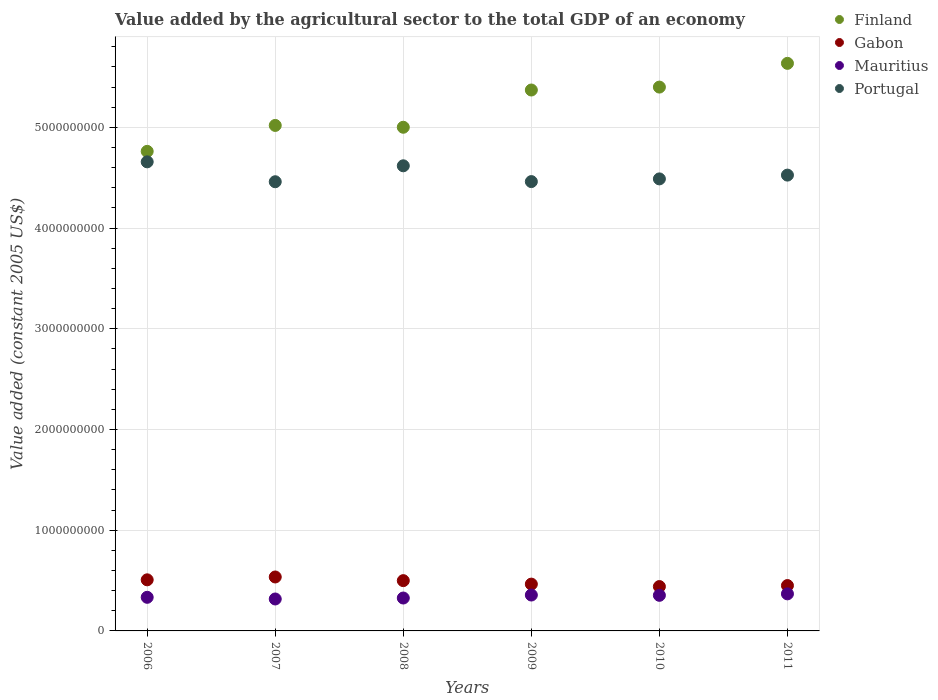How many different coloured dotlines are there?
Offer a terse response. 4. What is the value added by the agricultural sector in Mauritius in 2010?
Keep it short and to the point. 3.53e+08. Across all years, what is the maximum value added by the agricultural sector in Mauritius?
Make the answer very short. 3.68e+08. Across all years, what is the minimum value added by the agricultural sector in Finland?
Keep it short and to the point. 4.76e+09. In which year was the value added by the agricultural sector in Mauritius maximum?
Keep it short and to the point. 2011. In which year was the value added by the agricultural sector in Finland minimum?
Your answer should be compact. 2006. What is the total value added by the agricultural sector in Portugal in the graph?
Offer a very short reply. 2.72e+1. What is the difference between the value added by the agricultural sector in Mauritius in 2007 and that in 2010?
Give a very brief answer. -3.64e+07. What is the difference between the value added by the agricultural sector in Finland in 2011 and the value added by the agricultural sector in Mauritius in 2008?
Provide a succinct answer. 5.31e+09. What is the average value added by the agricultural sector in Portugal per year?
Keep it short and to the point. 4.54e+09. In the year 2008, what is the difference between the value added by the agricultural sector in Gabon and value added by the agricultural sector in Portugal?
Offer a terse response. -4.12e+09. In how many years, is the value added by the agricultural sector in Mauritius greater than 400000000 US$?
Keep it short and to the point. 0. What is the ratio of the value added by the agricultural sector in Mauritius in 2008 to that in 2011?
Provide a succinct answer. 0.89. Is the value added by the agricultural sector in Mauritius in 2006 less than that in 2010?
Your response must be concise. Yes. Is the difference between the value added by the agricultural sector in Gabon in 2008 and 2010 greater than the difference between the value added by the agricultural sector in Portugal in 2008 and 2010?
Keep it short and to the point. No. What is the difference between the highest and the second highest value added by the agricultural sector in Gabon?
Offer a very short reply. 2.83e+07. What is the difference between the highest and the lowest value added by the agricultural sector in Gabon?
Offer a very short reply. 9.51e+07. Is the sum of the value added by the agricultural sector in Mauritius in 2008 and 2009 greater than the maximum value added by the agricultural sector in Finland across all years?
Your response must be concise. No. Is the value added by the agricultural sector in Portugal strictly greater than the value added by the agricultural sector in Gabon over the years?
Offer a terse response. Yes. How many years are there in the graph?
Provide a succinct answer. 6. How many legend labels are there?
Keep it short and to the point. 4. How are the legend labels stacked?
Provide a short and direct response. Vertical. What is the title of the graph?
Ensure brevity in your answer.  Value added by the agricultural sector to the total GDP of an economy. Does "Indonesia" appear as one of the legend labels in the graph?
Your answer should be very brief. No. What is the label or title of the X-axis?
Keep it short and to the point. Years. What is the label or title of the Y-axis?
Ensure brevity in your answer.  Value added (constant 2005 US$). What is the Value added (constant 2005 US$) of Finland in 2006?
Keep it short and to the point. 4.76e+09. What is the Value added (constant 2005 US$) in Gabon in 2006?
Make the answer very short. 5.07e+08. What is the Value added (constant 2005 US$) in Mauritius in 2006?
Your answer should be compact. 3.34e+08. What is the Value added (constant 2005 US$) in Portugal in 2006?
Your response must be concise. 4.66e+09. What is the Value added (constant 2005 US$) of Finland in 2007?
Make the answer very short. 5.02e+09. What is the Value added (constant 2005 US$) of Gabon in 2007?
Your response must be concise. 5.36e+08. What is the Value added (constant 2005 US$) in Mauritius in 2007?
Keep it short and to the point. 3.17e+08. What is the Value added (constant 2005 US$) in Portugal in 2007?
Ensure brevity in your answer.  4.46e+09. What is the Value added (constant 2005 US$) of Finland in 2008?
Give a very brief answer. 5.00e+09. What is the Value added (constant 2005 US$) of Gabon in 2008?
Your answer should be very brief. 4.99e+08. What is the Value added (constant 2005 US$) of Mauritius in 2008?
Your answer should be very brief. 3.27e+08. What is the Value added (constant 2005 US$) of Portugal in 2008?
Keep it short and to the point. 4.62e+09. What is the Value added (constant 2005 US$) of Finland in 2009?
Keep it short and to the point. 5.37e+09. What is the Value added (constant 2005 US$) of Gabon in 2009?
Your answer should be very brief. 4.65e+08. What is the Value added (constant 2005 US$) in Mauritius in 2009?
Make the answer very short. 3.56e+08. What is the Value added (constant 2005 US$) of Portugal in 2009?
Offer a terse response. 4.46e+09. What is the Value added (constant 2005 US$) in Finland in 2010?
Your answer should be compact. 5.40e+09. What is the Value added (constant 2005 US$) of Gabon in 2010?
Provide a succinct answer. 4.40e+08. What is the Value added (constant 2005 US$) of Mauritius in 2010?
Ensure brevity in your answer.  3.53e+08. What is the Value added (constant 2005 US$) of Portugal in 2010?
Ensure brevity in your answer.  4.49e+09. What is the Value added (constant 2005 US$) of Finland in 2011?
Offer a very short reply. 5.64e+09. What is the Value added (constant 2005 US$) in Gabon in 2011?
Your answer should be compact. 4.50e+08. What is the Value added (constant 2005 US$) of Mauritius in 2011?
Your answer should be very brief. 3.68e+08. What is the Value added (constant 2005 US$) of Portugal in 2011?
Ensure brevity in your answer.  4.53e+09. Across all years, what is the maximum Value added (constant 2005 US$) in Finland?
Offer a very short reply. 5.64e+09. Across all years, what is the maximum Value added (constant 2005 US$) in Gabon?
Offer a very short reply. 5.36e+08. Across all years, what is the maximum Value added (constant 2005 US$) in Mauritius?
Give a very brief answer. 3.68e+08. Across all years, what is the maximum Value added (constant 2005 US$) in Portugal?
Provide a succinct answer. 4.66e+09. Across all years, what is the minimum Value added (constant 2005 US$) of Finland?
Make the answer very short. 4.76e+09. Across all years, what is the minimum Value added (constant 2005 US$) of Gabon?
Your response must be concise. 4.40e+08. Across all years, what is the minimum Value added (constant 2005 US$) of Mauritius?
Your answer should be very brief. 3.17e+08. Across all years, what is the minimum Value added (constant 2005 US$) of Portugal?
Offer a terse response. 4.46e+09. What is the total Value added (constant 2005 US$) of Finland in the graph?
Your answer should be compact. 3.12e+1. What is the total Value added (constant 2005 US$) of Gabon in the graph?
Give a very brief answer. 2.90e+09. What is the total Value added (constant 2005 US$) of Mauritius in the graph?
Make the answer very short. 2.06e+09. What is the total Value added (constant 2005 US$) of Portugal in the graph?
Keep it short and to the point. 2.72e+1. What is the difference between the Value added (constant 2005 US$) of Finland in 2006 and that in 2007?
Offer a very short reply. -2.57e+08. What is the difference between the Value added (constant 2005 US$) in Gabon in 2006 and that in 2007?
Provide a short and direct response. -2.83e+07. What is the difference between the Value added (constant 2005 US$) in Mauritius in 2006 and that in 2007?
Your answer should be very brief. 1.67e+07. What is the difference between the Value added (constant 2005 US$) in Portugal in 2006 and that in 2007?
Provide a succinct answer. 1.98e+08. What is the difference between the Value added (constant 2005 US$) of Finland in 2006 and that in 2008?
Give a very brief answer. -2.39e+08. What is the difference between the Value added (constant 2005 US$) of Gabon in 2006 and that in 2008?
Provide a short and direct response. 8.09e+06. What is the difference between the Value added (constant 2005 US$) of Mauritius in 2006 and that in 2008?
Offer a terse response. 7.18e+06. What is the difference between the Value added (constant 2005 US$) in Portugal in 2006 and that in 2008?
Ensure brevity in your answer.  3.93e+07. What is the difference between the Value added (constant 2005 US$) of Finland in 2006 and that in 2009?
Your answer should be compact. -6.09e+08. What is the difference between the Value added (constant 2005 US$) in Gabon in 2006 and that in 2009?
Make the answer very short. 4.26e+07. What is the difference between the Value added (constant 2005 US$) of Mauritius in 2006 and that in 2009?
Your answer should be very brief. -2.25e+07. What is the difference between the Value added (constant 2005 US$) in Portugal in 2006 and that in 2009?
Ensure brevity in your answer.  1.96e+08. What is the difference between the Value added (constant 2005 US$) of Finland in 2006 and that in 2010?
Offer a terse response. -6.38e+08. What is the difference between the Value added (constant 2005 US$) of Gabon in 2006 and that in 2010?
Your response must be concise. 6.69e+07. What is the difference between the Value added (constant 2005 US$) of Mauritius in 2006 and that in 2010?
Offer a very short reply. -1.97e+07. What is the difference between the Value added (constant 2005 US$) of Portugal in 2006 and that in 2010?
Make the answer very short. 1.69e+08. What is the difference between the Value added (constant 2005 US$) in Finland in 2006 and that in 2011?
Make the answer very short. -8.74e+08. What is the difference between the Value added (constant 2005 US$) of Gabon in 2006 and that in 2011?
Give a very brief answer. 5.69e+07. What is the difference between the Value added (constant 2005 US$) in Mauritius in 2006 and that in 2011?
Ensure brevity in your answer.  -3.42e+07. What is the difference between the Value added (constant 2005 US$) in Portugal in 2006 and that in 2011?
Ensure brevity in your answer.  1.32e+08. What is the difference between the Value added (constant 2005 US$) in Finland in 2007 and that in 2008?
Offer a very short reply. 1.81e+07. What is the difference between the Value added (constant 2005 US$) of Gabon in 2007 and that in 2008?
Make the answer very short. 3.63e+07. What is the difference between the Value added (constant 2005 US$) in Mauritius in 2007 and that in 2008?
Offer a very short reply. -9.51e+06. What is the difference between the Value added (constant 2005 US$) in Portugal in 2007 and that in 2008?
Give a very brief answer. -1.58e+08. What is the difference between the Value added (constant 2005 US$) in Finland in 2007 and that in 2009?
Give a very brief answer. -3.52e+08. What is the difference between the Value added (constant 2005 US$) of Gabon in 2007 and that in 2009?
Keep it short and to the point. 7.09e+07. What is the difference between the Value added (constant 2005 US$) of Mauritius in 2007 and that in 2009?
Your answer should be very brief. -3.92e+07. What is the difference between the Value added (constant 2005 US$) in Portugal in 2007 and that in 2009?
Provide a succinct answer. -1.43e+06. What is the difference between the Value added (constant 2005 US$) of Finland in 2007 and that in 2010?
Provide a short and direct response. -3.81e+08. What is the difference between the Value added (constant 2005 US$) in Gabon in 2007 and that in 2010?
Your response must be concise. 9.51e+07. What is the difference between the Value added (constant 2005 US$) of Mauritius in 2007 and that in 2010?
Your answer should be very brief. -3.64e+07. What is the difference between the Value added (constant 2005 US$) of Portugal in 2007 and that in 2010?
Ensure brevity in your answer.  -2.83e+07. What is the difference between the Value added (constant 2005 US$) of Finland in 2007 and that in 2011?
Offer a very short reply. -6.16e+08. What is the difference between the Value added (constant 2005 US$) in Gabon in 2007 and that in 2011?
Keep it short and to the point. 8.52e+07. What is the difference between the Value added (constant 2005 US$) in Mauritius in 2007 and that in 2011?
Give a very brief answer. -5.09e+07. What is the difference between the Value added (constant 2005 US$) of Portugal in 2007 and that in 2011?
Your response must be concise. -6.58e+07. What is the difference between the Value added (constant 2005 US$) of Finland in 2008 and that in 2009?
Offer a terse response. -3.70e+08. What is the difference between the Value added (constant 2005 US$) of Gabon in 2008 and that in 2009?
Provide a short and direct response. 3.45e+07. What is the difference between the Value added (constant 2005 US$) of Mauritius in 2008 and that in 2009?
Keep it short and to the point. -2.97e+07. What is the difference between the Value added (constant 2005 US$) of Portugal in 2008 and that in 2009?
Offer a terse response. 1.57e+08. What is the difference between the Value added (constant 2005 US$) in Finland in 2008 and that in 2010?
Your answer should be very brief. -3.99e+08. What is the difference between the Value added (constant 2005 US$) in Gabon in 2008 and that in 2010?
Ensure brevity in your answer.  5.88e+07. What is the difference between the Value added (constant 2005 US$) in Mauritius in 2008 and that in 2010?
Provide a short and direct response. -2.69e+07. What is the difference between the Value added (constant 2005 US$) of Portugal in 2008 and that in 2010?
Make the answer very short. 1.30e+08. What is the difference between the Value added (constant 2005 US$) of Finland in 2008 and that in 2011?
Your answer should be compact. -6.34e+08. What is the difference between the Value added (constant 2005 US$) in Gabon in 2008 and that in 2011?
Provide a succinct answer. 4.89e+07. What is the difference between the Value added (constant 2005 US$) of Mauritius in 2008 and that in 2011?
Your answer should be very brief. -4.14e+07. What is the difference between the Value added (constant 2005 US$) in Portugal in 2008 and that in 2011?
Provide a short and direct response. 9.24e+07. What is the difference between the Value added (constant 2005 US$) in Finland in 2009 and that in 2010?
Your answer should be compact. -2.90e+07. What is the difference between the Value added (constant 2005 US$) of Gabon in 2009 and that in 2010?
Make the answer very short. 2.42e+07. What is the difference between the Value added (constant 2005 US$) of Mauritius in 2009 and that in 2010?
Give a very brief answer. 2.85e+06. What is the difference between the Value added (constant 2005 US$) in Portugal in 2009 and that in 2010?
Your response must be concise. -2.68e+07. What is the difference between the Value added (constant 2005 US$) of Finland in 2009 and that in 2011?
Make the answer very short. -2.65e+08. What is the difference between the Value added (constant 2005 US$) in Gabon in 2009 and that in 2011?
Ensure brevity in your answer.  1.43e+07. What is the difference between the Value added (constant 2005 US$) in Mauritius in 2009 and that in 2011?
Make the answer very short. -1.16e+07. What is the difference between the Value added (constant 2005 US$) in Portugal in 2009 and that in 2011?
Your response must be concise. -6.44e+07. What is the difference between the Value added (constant 2005 US$) in Finland in 2010 and that in 2011?
Offer a terse response. -2.36e+08. What is the difference between the Value added (constant 2005 US$) of Gabon in 2010 and that in 2011?
Your response must be concise. -9.92e+06. What is the difference between the Value added (constant 2005 US$) in Mauritius in 2010 and that in 2011?
Make the answer very short. -1.45e+07. What is the difference between the Value added (constant 2005 US$) in Portugal in 2010 and that in 2011?
Offer a very short reply. -3.76e+07. What is the difference between the Value added (constant 2005 US$) of Finland in 2006 and the Value added (constant 2005 US$) of Gabon in 2007?
Offer a terse response. 4.23e+09. What is the difference between the Value added (constant 2005 US$) of Finland in 2006 and the Value added (constant 2005 US$) of Mauritius in 2007?
Your response must be concise. 4.44e+09. What is the difference between the Value added (constant 2005 US$) in Finland in 2006 and the Value added (constant 2005 US$) in Portugal in 2007?
Give a very brief answer. 3.02e+08. What is the difference between the Value added (constant 2005 US$) in Gabon in 2006 and the Value added (constant 2005 US$) in Mauritius in 2007?
Offer a very short reply. 1.90e+08. What is the difference between the Value added (constant 2005 US$) of Gabon in 2006 and the Value added (constant 2005 US$) of Portugal in 2007?
Your response must be concise. -3.95e+09. What is the difference between the Value added (constant 2005 US$) of Mauritius in 2006 and the Value added (constant 2005 US$) of Portugal in 2007?
Ensure brevity in your answer.  -4.13e+09. What is the difference between the Value added (constant 2005 US$) in Finland in 2006 and the Value added (constant 2005 US$) in Gabon in 2008?
Provide a short and direct response. 4.26e+09. What is the difference between the Value added (constant 2005 US$) of Finland in 2006 and the Value added (constant 2005 US$) of Mauritius in 2008?
Provide a short and direct response. 4.43e+09. What is the difference between the Value added (constant 2005 US$) in Finland in 2006 and the Value added (constant 2005 US$) in Portugal in 2008?
Your answer should be very brief. 1.43e+08. What is the difference between the Value added (constant 2005 US$) of Gabon in 2006 and the Value added (constant 2005 US$) of Mauritius in 2008?
Provide a succinct answer. 1.81e+08. What is the difference between the Value added (constant 2005 US$) of Gabon in 2006 and the Value added (constant 2005 US$) of Portugal in 2008?
Ensure brevity in your answer.  -4.11e+09. What is the difference between the Value added (constant 2005 US$) of Mauritius in 2006 and the Value added (constant 2005 US$) of Portugal in 2008?
Keep it short and to the point. -4.28e+09. What is the difference between the Value added (constant 2005 US$) in Finland in 2006 and the Value added (constant 2005 US$) in Gabon in 2009?
Provide a short and direct response. 4.30e+09. What is the difference between the Value added (constant 2005 US$) of Finland in 2006 and the Value added (constant 2005 US$) of Mauritius in 2009?
Give a very brief answer. 4.41e+09. What is the difference between the Value added (constant 2005 US$) in Finland in 2006 and the Value added (constant 2005 US$) in Portugal in 2009?
Your response must be concise. 3.00e+08. What is the difference between the Value added (constant 2005 US$) in Gabon in 2006 and the Value added (constant 2005 US$) in Mauritius in 2009?
Offer a very short reply. 1.51e+08. What is the difference between the Value added (constant 2005 US$) of Gabon in 2006 and the Value added (constant 2005 US$) of Portugal in 2009?
Offer a very short reply. -3.95e+09. What is the difference between the Value added (constant 2005 US$) of Mauritius in 2006 and the Value added (constant 2005 US$) of Portugal in 2009?
Offer a terse response. -4.13e+09. What is the difference between the Value added (constant 2005 US$) in Finland in 2006 and the Value added (constant 2005 US$) in Gabon in 2010?
Give a very brief answer. 4.32e+09. What is the difference between the Value added (constant 2005 US$) of Finland in 2006 and the Value added (constant 2005 US$) of Mauritius in 2010?
Offer a terse response. 4.41e+09. What is the difference between the Value added (constant 2005 US$) in Finland in 2006 and the Value added (constant 2005 US$) in Portugal in 2010?
Your response must be concise. 2.73e+08. What is the difference between the Value added (constant 2005 US$) in Gabon in 2006 and the Value added (constant 2005 US$) in Mauritius in 2010?
Your answer should be compact. 1.54e+08. What is the difference between the Value added (constant 2005 US$) in Gabon in 2006 and the Value added (constant 2005 US$) in Portugal in 2010?
Give a very brief answer. -3.98e+09. What is the difference between the Value added (constant 2005 US$) in Mauritius in 2006 and the Value added (constant 2005 US$) in Portugal in 2010?
Your response must be concise. -4.15e+09. What is the difference between the Value added (constant 2005 US$) of Finland in 2006 and the Value added (constant 2005 US$) of Gabon in 2011?
Make the answer very short. 4.31e+09. What is the difference between the Value added (constant 2005 US$) in Finland in 2006 and the Value added (constant 2005 US$) in Mauritius in 2011?
Offer a terse response. 4.39e+09. What is the difference between the Value added (constant 2005 US$) in Finland in 2006 and the Value added (constant 2005 US$) in Portugal in 2011?
Offer a very short reply. 2.36e+08. What is the difference between the Value added (constant 2005 US$) in Gabon in 2006 and the Value added (constant 2005 US$) in Mauritius in 2011?
Provide a succinct answer. 1.39e+08. What is the difference between the Value added (constant 2005 US$) in Gabon in 2006 and the Value added (constant 2005 US$) in Portugal in 2011?
Your answer should be compact. -4.02e+09. What is the difference between the Value added (constant 2005 US$) of Mauritius in 2006 and the Value added (constant 2005 US$) of Portugal in 2011?
Offer a very short reply. -4.19e+09. What is the difference between the Value added (constant 2005 US$) of Finland in 2007 and the Value added (constant 2005 US$) of Gabon in 2008?
Offer a very short reply. 4.52e+09. What is the difference between the Value added (constant 2005 US$) of Finland in 2007 and the Value added (constant 2005 US$) of Mauritius in 2008?
Keep it short and to the point. 4.69e+09. What is the difference between the Value added (constant 2005 US$) of Finland in 2007 and the Value added (constant 2005 US$) of Portugal in 2008?
Ensure brevity in your answer.  4.01e+08. What is the difference between the Value added (constant 2005 US$) of Gabon in 2007 and the Value added (constant 2005 US$) of Mauritius in 2008?
Provide a short and direct response. 2.09e+08. What is the difference between the Value added (constant 2005 US$) of Gabon in 2007 and the Value added (constant 2005 US$) of Portugal in 2008?
Make the answer very short. -4.08e+09. What is the difference between the Value added (constant 2005 US$) in Mauritius in 2007 and the Value added (constant 2005 US$) in Portugal in 2008?
Your response must be concise. -4.30e+09. What is the difference between the Value added (constant 2005 US$) of Finland in 2007 and the Value added (constant 2005 US$) of Gabon in 2009?
Offer a terse response. 4.55e+09. What is the difference between the Value added (constant 2005 US$) in Finland in 2007 and the Value added (constant 2005 US$) in Mauritius in 2009?
Your answer should be very brief. 4.66e+09. What is the difference between the Value added (constant 2005 US$) of Finland in 2007 and the Value added (constant 2005 US$) of Portugal in 2009?
Your answer should be very brief. 5.58e+08. What is the difference between the Value added (constant 2005 US$) of Gabon in 2007 and the Value added (constant 2005 US$) of Mauritius in 2009?
Ensure brevity in your answer.  1.79e+08. What is the difference between the Value added (constant 2005 US$) of Gabon in 2007 and the Value added (constant 2005 US$) of Portugal in 2009?
Ensure brevity in your answer.  -3.93e+09. What is the difference between the Value added (constant 2005 US$) of Mauritius in 2007 and the Value added (constant 2005 US$) of Portugal in 2009?
Your response must be concise. -4.14e+09. What is the difference between the Value added (constant 2005 US$) in Finland in 2007 and the Value added (constant 2005 US$) in Gabon in 2010?
Give a very brief answer. 4.58e+09. What is the difference between the Value added (constant 2005 US$) of Finland in 2007 and the Value added (constant 2005 US$) of Mauritius in 2010?
Your answer should be compact. 4.67e+09. What is the difference between the Value added (constant 2005 US$) of Finland in 2007 and the Value added (constant 2005 US$) of Portugal in 2010?
Keep it short and to the point. 5.31e+08. What is the difference between the Value added (constant 2005 US$) of Gabon in 2007 and the Value added (constant 2005 US$) of Mauritius in 2010?
Ensure brevity in your answer.  1.82e+08. What is the difference between the Value added (constant 2005 US$) of Gabon in 2007 and the Value added (constant 2005 US$) of Portugal in 2010?
Offer a very short reply. -3.95e+09. What is the difference between the Value added (constant 2005 US$) in Mauritius in 2007 and the Value added (constant 2005 US$) in Portugal in 2010?
Keep it short and to the point. -4.17e+09. What is the difference between the Value added (constant 2005 US$) of Finland in 2007 and the Value added (constant 2005 US$) of Gabon in 2011?
Your response must be concise. 4.57e+09. What is the difference between the Value added (constant 2005 US$) in Finland in 2007 and the Value added (constant 2005 US$) in Mauritius in 2011?
Your answer should be compact. 4.65e+09. What is the difference between the Value added (constant 2005 US$) in Finland in 2007 and the Value added (constant 2005 US$) in Portugal in 2011?
Ensure brevity in your answer.  4.93e+08. What is the difference between the Value added (constant 2005 US$) in Gabon in 2007 and the Value added (constant 2005 US$) in Mauritius in 2011?
Give a very brief answer. 1.68e+08. What is the difference between the Value added (constant 2005 US$) in Gabon in 2007 and the Value added (constant 2005 US$) in Portugal in 2011?
Provide a short and direct response. -3.99e+09. What is the difference between the Value added (constant 2005 US$) of Mauritius in 2007 and the Value added (constant 2005 US$) of Portugal in 2011?
Offer a terse response. -4.21e+09. What is the difference between the Value added (constant 2005 US$) in Finland in 2008 and the Value added (constant 2005 US$) in Gabon in 2009?
Offer a terse response. 4.54e+09. What is the difference between the Value added (constant 2005 US$) in Finland in 2008 and the Value added (constant 2005 US$) in Mauritius in 2009?
Provide a short and direct response. 4.64e+09. What is the difference between the Value added (constant 2005 US$) in Finland in 2008 and the Value added (constant 2005 US$) in Portugal in 2009?
Your response must be concise. 5.40e+08. What is the difference between the Value added (constant 2005 US$) of Gabon in 2008 and the Value added (constant 2005 US$) of Mauritius in 2009?
Ensure brevity in your answer.  1.43e+08. What is the difference between the Value added (constant 2005 US$) of Gabon in 2008 and the Value added (constant 2005 US$) of Portugal in 2009?
Offer a terse response. -3.96e+09. What is the difference between the Value added (constant 2005 US$) in Mauritius in 2008 and the Value added (constant 2005 US$) in Portugal in 2009?
Give a very brief answer. -4.13e+09. What is the difference between the Value added (constant 2005 US$) in Finland in 2008 and the Value added (constant 2005 US$) in Gabon in 2010?
Offer a terse response. 4.56e+09. What is the difference between the Value added (constant 2005 US$) in Finland in 2008 and the Value added (constant 2005 US$) in Mauritius in 2010?
Provide a succinct answer. 4.65e+09. What is the difference between the Value added (constant 2005 US$) in Finland in 2008 and the Value added (constant 2005 US$) in Portugal in 2010?
Your answer should be very brief. 5.13e+08. What is the difference between the Value added (constant 2005 US$) in Gabon in 2008 and the Value added (constant 2005 US$) in Mauritius in 2010?
Make the answer very short. 1.46e+08. What is the difference between the Value added (constant 2005 US$) of Gabon in 2008 and the Value added (constant 2005 US$) of Portugal in 2010?
Provide a succinct answer. -3.99e+09. What is the difference between the Value added (constant 2005 US$) in Mauritius in 2008 and the Value added (constant 2005 US$) in Portugal in 2010?
Provide a short and direct response. -4.16e+09. What is the difference between the Value added (constant 2005 US$) of Finland in 2008 and the Value added (constant 2005 US$) of Gabon in 2011?
Make the answer very short. 4.55e+09. What is the difference between the Value added (constant 2005 US$) of Finland in 2008 and the Value added (constant 2005 US$) of Mauritius in 2011?
Your response must be concise. 4.63e+09. What is the difference between the Value added (constant 2005 US$) in Finland in 2008 and the Value added (constant 2005 US$) in Portugal in 2011?
Provide a short and direct response. 4.75e+08. What is the difference between the Value added (constant 2005 US$) in Gabon in 2008 and the Value added (constant 2005 US$) in Mauritius in 2011?
Provide a succinct answer. 1.31e+08. What is the difference between the Value added (constant 2005 US$) of Gabon in 2008 and the Value added (constant 2005 US$) of Portugal in 2011?
Ensure brevity in your answer.  -4.03e+09. What is the difference between the Value added (constant 2005 US$) of Mauritius in 2008 and the Value added (constant 2005 US$) of Portugal in 2011?
Your answer should be very brief. -4.20e+09. What is the difference between the Value added (constant 2005 US$) of Finland in 2009 and the Value added (constant 2005 US$) of Gabon in 2010?
Offer a terse response. 4.93e+09. What is the difference between the Value added (constant 2005 US$) of Finland in 2009 and the Value added (constant 2005 US$) of Mauritius in 2010?
Your answer should be very brief. 5.02e+09. What is the difference between the Value added (constant 2005 US$) of Finland in 2009 and the Value added (constant 2005 US$) of Portugal in 2010?
Offer a very short reply. 8.82e+08. What is the difference between the Value added (constant 2005 US$) of Gabon in 2009 and the Value added (constant 2005 US$) of Mauritius in 2010?
Give a very brief answer. 1.11e+08. What is the difference between the Value added (constant 2005 US$) in Gabon in 2009 and the Value added (constant 2005 US$) in Portugal in 2010?
Make the answer very short. -4.02e+09. What is the difference between the Value added (constant 2005 US$) of Mauritius in 2009 and the Value added (constant 2005 US$) of Portugal in 2010?
Your answer should be very brief. -4.13e+09. What is the difference between the Value added (constant 2005 US$) in Finland in 2009 and the Value added (constant 2005 US$) in Gabon in 2011?
Offer a terse response. 4.92e+09. What is the difference between the Value added (constant 2005 US$) in Finland in 2009 and the Value added (constant 2005 US$) in Mauritius in 2011?
Offer a very short reply. 5.00e+09. What is the difference between the Value added (constant 2005 US$) in Finland in 2009 and the Value added (constant 2005 US$) in Portugal in 2011?
Your response must be concise. 8.45e+08. What is the difference between the Value added (constant 2005 US$) of Gabon in 2009 and the Value added (constant 2005 US$) of Mauritius in 2011?
Keep it short and to the point. 9.67e+07. What is the difference between the Value added (constant 2005 US$) of Gabon in 2009 and the Value added (constant 2005 US$) of Portugal in 2011?
Offer a terse response. -4.06e+09. What is the difference between the Value added (constant 2005 US$) in Mauritius in 2009 and the Value added (constant 2005 US$) in Portugal in 2011?
Keep it short and to the point. -4.17e+09. What is the difference between the Value added (constant 2005 US$) of Finland in 2010 and the Value added (constant 2005 US$) of Gabon in 2011?
Offer a terse response. 4.95e+09. What is the difference between the Value added (constant 2005 US$) in Finland in 2010 and the Value added (constant 2005 US$) in Mauritius in 2011?
Your answer should be compact. 5.03e+09. What is the difference between the Value added (constant 2005 US$) in Finland in 2010 and the Value added (constant 2005 US$) in Portugal in 2011?
Provide a succinct answer. 8.74e+08. What is the difference between the Value added (constant 2005 US$) in Gabon in 2010 and the Value added (constant 2005 US$) in Mauritius in 2011?
Your response must be concise. 7.25e+07. What is the difference between the Value added (constant 2005 US$) of Gabon in 2010 and the Value added (constant 2005 US$) of Portugal in 2011?
Give a very brief answer. -4.09e+09. What is the difference between the Value added (constant 2005 US$) of Mauritius in 2010 and the Value added (constant 2005 US$) of Portugal in 2011?
Your response must be concise. -4.17e+09. What is the average Value added (constant 2005 US$) in Finland per year?
Provide a short and direct response. 5.20e+09. What is the average Value added (constant 2005 US$) in Gabon per year?
Your answer should be very brief. 4.83e+08. What is the average Value added (constant 2005 US$) of Mauritius per year?
Your response must be concise. 3.43e+08. What is the average Value added (constant 2005 US$) in Portugal per year?
Make the answer very short. 4.54e+09. In the year 2006, what is the difference between the Value added (constant 2005 US$) in Finland and Value added (constant 2005 US$) in Gabon?
Offer a very short reply. 4.25e+09. In the year 2006, what is the difference between the Value added (constant 2005 US$) in Finland and Value added (constant 2005 US$) in Mauritius?
Your answer should be compact. 4.43e+09. In the year 2006, what is the difference between the Value added (constant 2005 US$) of Finland and Value added (constant 2005 US$) of Portugal?
Provide a short and direct response. 1.04e+08. In the year 2006, what is the difference between the Value added (constant 2005 US$) in Gabon and Value added (constant 2005 US$) in Mauritius?
Your answer should be very brief. 1.74e+08. In the year 2006, what is the difference between the Value added (constant 2005 US$) of Gabon and Value added (constant 2005 US$) of Portugal?
Offer a very short reply. -4.15e+09. In the year 2006, what is the difference between the Value added (constant 2005 US$) in Mauritius and Value added (constant 2005 US$) in Portugal?
Ensure brevity in your answer.  -4.32e+09. In the year 2007, what is the difference between the Value added (constant 2005 US$) of Finland and Value added (constant 2005 US$) of Gabon?
Your answer should be very brief. 4.48e+09. In the year 2007, what is the difference between the Value added (constant 2005 US$) in Finland and Value added (constant 2005 US$) in Mauritius?
Your answer should be compact. 4.70e+09. In the year 2007, what is the difference between the Value added (constant 2005 US$) of Finland and Value added (constant 2005 US$) of Portugal?
Keep it short and to the point. 5.59e+08. In the year 2007, what is the difference between the Value added (constant 2005 US$) in Gabon and Value added (constant 2005 US$) in Mauritius?
Provide a short and direct response. 2.18e+08. In the year 2007, what is the difference between the Value added (constant 2005 US$) of Gabon and Value added (constant 2005 US$) of Portugal?
Provide a short and direct response. -3.92e+09. In the year 2007, what is the difference between the Value added (constant 2005 US$) in Mauritius and Value added (constant 2005 US$) in Portugal?
Your answer should be compact. -4.14e+09. In the year 2008, what is the difference between the Value added (constant 2005 US$) in Finland and Value added (constant 2005 US$) in Gabon?
Provide a short and direct response. 4.50e+09. In the year 2008, what is the difference between the Value added (constant 2005 US$) of Finland and Value added (constant 2005 US$) of Mauritius?
Provide a short and direct response. 4.67e+09. In the year 2008, what is the difference between the Value added (constant 2005 US$) in Finland and Value added (constant 2005 US$) in Portugal?
Your response must be concise. 3.83e+08. In the year 2008, what is the difference between the Value added (constant 2005 US$) of Gabon and Value added (constant 2005 US$) of Mauritius?
Your answer should be very brief. 1.73e+08. In the year 2008, what is the difference between the Value added (constant 2005 US$) of Gabon and Value added (constant 2005 US$) of Portugal?
Offer a terse response. -4.12e+09. In the year 2008, what is the difference between the Value added (constant 2005 US$) of Mauritius and Value added (constant 2005 US$) of Portugal?
Give a very brief answer. -4.29e+09. In the year 2009, what is the difference between the Value added (constant 2005 US$) of Finland and Value added (constant 2005 US$) of Gabon?
Your answer should be compact. 4.91e+09. In the year 2009, what is the difference between the Value added (constant 2005 US$) in Finland and Value added (constant 2005 US$) in Mauritius?
Keep it short and to the point. 5.01e+09. In the year 2009, what is the difference between the Value added (constant 2005 US$) in Finland and Value added (constant 2005 US$) in Portugal?
Offer a very short reply. 9.09e+08. In the year 2009, what is the difference between the Value added (constant 2005 US$) of Gabon and Value added (constant 2005 US$) of Mauritius?
Your answer should be compact. 1.08e+08. In the year 2009, what is the difference between the Value added (constant 2005 US$) of Gabon and Value added (constant 2005 US$) of Portugal?
Provide a short and direct response. -4.00e+09. In the year 2009, what is the difference between the Value added (constant 2005 US$) in Mauritius and Value added (constant 2005 US$) in Portugal?
Offer a very short reply. -4.11e+09. In the year 2010, what is the difference between the Value added (constant 2005 US$) in Finland and Value added (constant 2005 US$) in Gabon?
Offer a very short reply. 4.96e+09. In the year 2010, what is the difference between the Value added (constant 2005 US$) in Finland and Value added (constant 2005 US$) in Mauritius?
Offer a very short reply. 5.05e+09. In the year 2010, what is the difference between the Value added (constant 2005 US$) in Finland and Value added (constant 2005 US$) in Portugal?
Make the answer very short. 9.11e+08. In the year 2010, what is the difference between the Value added (constant 2005 US$) in Gabon and Value added (constant 2005 US$) in Mauritius?
Keep it short and to the point. 8.70e+07. In the year 2010, what is the difference between the Value added (constant 2005 US$) of Gabon and Value added (constant 2005 US$) of Portugal?
Your answer should be compact. -4.05e+09. In the year 2010, what is the difference between the Value added (constant 2005 US$) in Mauritius and Value added (constant 2005 US$) in Portugal?
Give a very brief answer. -4.13e+09. In the year 2011, what is the difference between the Value added (constant 2005 US$) in Finland and Value added (constant 2005 US$) in Gabon?
Make the answer very short. 5.18e+09. In the year 2011, what is the difference between the Value added (constant 2005 US$) in Finland and Value added (constant 2005 US$) in Mauritius?
Provide a short and direct response. 5.27e+09. In the year 2011, what is the difference between the Value added (constant 2005 US$) of Finland and Value added (constant 2005 US$) of Portugal?
Provide a short and direct response. 1.11e+09. In the year 2011, what is the difference between the Value added (constant 2005 US$) in Gabon and Value added (constant 2005 US$) in Mauritius?
Your answer should be compact. 8.24e+07. In the year 2011, what is the difference between the Value added (constant 2005 US$) in Gabon and Value added (constant 2005 US$) in Portugal?
Offer a very short reply. -4.08e+09. In the year 2011, what is the difference between the Value added (constant 2005 US$) in Mauritius and Value added (constant 2005 US$) in Portugal?
Provide a short and direct response. -4.16e+09. What is the ratio of the Value added (constant 2005 US$) of Finland in 2006 to that in 2007?
Offer a very short reply. 0.95. What is the ratio of the Value added (constant 2005 US$) of Gabon in 2006 to that in 2007?
Provide a short and direct response. 0.95. What is the ratio of the Value added (constant 2005 US$) in Mauritius in 2006 to that in 2007?
Provide a succinct answer. 1.05. What is the ratio of the Value added (constant 2005 US$) of Portugal in 2006 to that in 2007?
Offer a terse response. 1.04. What is the ratio of the Value added (constant 2005 US$) of Finland in 2006 to that in 2008?
Give a very brief answer. 0.95. What is the ratio of the Value added (constant 2005 US$) in Gabon in 2006 to that in 2008?
Offer a terse response. 1.02. What is the ratio of the Value added (constant 2005 US$) of Portugal in 2006 to that in 2008?
Offer a very short reply. 1.01. What is the ratio of the Value added (constant 2005 US$) in Finland in 2006 to that in 2009?
Your response must be concise. 0.89. What is the ratio of the Value added (constant 2005 US$) in Gabon in 2006 to that in 2009?
Provide a short and direct response. 1.09. What is the ratio of the Value added (constant 2005 US$) in Mauritius in 2006 to that in 2009?
Provide a succinct answer. 0.94. What is the ratio of the Value added (constant 2005 US$) of Portugal in 2006 to that in 2009?
Offer a terse response. 1.04. What is the ratio of the Value added (constant 2005 US$) in Finland in 2006 to that in 2010?
Offer a very short reply. 0.88. What is the ratio of the Value added (constant 2005 US$) in Gabon in 2006 to that in 2010?
Ensure brevity in your answer.  1.15. What is the ratio of the Value added (constant 2005 US$) in Mauritius in 2006 to that in 2010?
Give a very brief answer. 0.94. What is the ratio of the Value added (constant 2005 US$) of Portugal in 2006 to that in 2010?
Make the answer very short. 1.04. What is the ratio of the Value added (constant 2005 US$) of Finland in 2006 to that in 2011?
Your response must be concise. 0.84. What is the ratio of the Value added (constant 2005 US$) in Gabon in 2006 to that in 2011?
Make the answer very short. 1.13. What is the ratio of the Value added (constant 2005 US$) in Mauritius in 2006 to that in 2011?
Your response must be concise. 0.91. What is the ratio of the Value added (constant 2005 US$) in Portugal in 2006 to that in 2011?
Provide a short and direct response. 1.03. What is the ratio of the Value added (constant 2005 US$) in Finland in 2007 to that in 2008?
Provide a succinct answer. 1. What is the ratio of the Value added (constant 2005 US$) in Gabon in 2007 to that in 2008?
Offer a very short reply. 1.07. What is the ratio of the Value added (constant 2005 US$) in Mauritius in 2007 to that in 2008?
Provide a succinct answer. 0.97. What is the ratio of the Value added (constant 2005 US$) in Portugal in 2007 to that in 2008?
Give a very brief answer. 0.97. What is the ratio of the Value added (constant 2005 US$) of Finland in 2007 to that in 2009?
Provide a succinct answer. 0.93. What is the ratio of the Value added (constant 2005 US$) of Gabon in 2007 to that in 2009?
Keep it short and to the point. 1.15. What is the ratio of the Value added (constant 2005 US$) in Mauritius in 2007 to that in 2009?
Offer a very short reply. 0.89. What is the ratio of the Value added (constant 2005 US$) in Portugal in 2007 to that in 2009?
Your response must be concise. 1. What is the ratio of the Value added (constant 2005 US$) in Finland in 2007 to that in 2010?
Ensure brevity in your answer.  0.93. What is the ratio of the Value added (constant 2005 US$) of Gabon in 2007 to that in 2010?
Provide a succinct answer. 1.22. What is the ratio of the Value added (constant 2005 US$) in Mauritius in 2007 to that in 2010?
Ensure brevity in your answer.  0.9. What is the ratio of the Value added (constant 2005 US$) of Portugal in 2007 to that in 2010?
Provide a short and direct response. 0.99. What is the ratio of the Value added (constant 2005 US$) in Finland in 2007 to that in 2011?
Provide a succinct answer. 0.89. What is the ratio of the Value added (constant 2005 US$) of Gabon in 2007 to that in 2011?
Your answer should be very brief. 1.19. What is the ratio of the Value added (constant 2005 US$) of Mauritius in 2007 to that in 2011?
Keep it short and to the point. 0.86. What is the ratio of the Value added (constant 2005 US$) of Portugal in 2007 to that in 2011?
Provide a succinct answer. 0.99. What is the ratio of the Value added (constant 2005 US$) in Finland in 2008 to that in 2009?
Your answer should be compact. 0.93. What is the ratio of the Value added (constant 2005 US$) in Gabon in 2008 to that in 2009?
Provide a succinct answer. 1.07. What is the ratio of the Value added (constant 2005 US$) in Mauritius in 2008 to that in 2009?
Offer a terse response. 0.92. What is the ratio of the Value added (constant 2005 US$) of Portugal in 2008 to that in 2009?
Offer a terse response. 1.04. What is the ratio of the Value added (constant 2005 US$) in Finland in 2008 to that in 2010?
Offer a very short reply. 0.93. What is the ratio of the Value added (constant 2005 US$) of Gabon in 2008 to that in 2010?
Provide a succinct answer. 1.13. What is the ratio of the Value added (constant 2005 US$) in Mauritius in 2008 to that in 2010?
Make the answer very short. 0.92. What is the ratio of the Value added (constant 2005 US$) of Portugal in 2008 to that in 2010?
Make the answer very short. 1.03. What is the ratio of the Value added (constant 2005 US$) of Finland in 2008 to that in 2011?
Provide a succinct answer. 0.89. What is the ratio of the Value added (constant 2005 US$) in Gabon in 2008 to that in 2011?
Ensure brevity in your answer.  1.11. What is the ratio of the Value added (constant 2005 US$) of Mauritius in 2008 to that in 2011?
Make the answer very short. 0.89. What is the ratio of the Value added (constant 2005 US$) in Portugal in 2008 to that in 2011?
Offer a very short reply. 1.02. What is the ratio of the Value added (constant 2005 US$) of Gabon in 2009 to that in 2010?
Offer a very short reply. 1.05. What is the ratio of the Value added (constant 2005 US$) in Mauritius in 2009 to that in 2010?
Your answer should be very brief. 1.01. What is the ratio of the Value added (constant 2005 US$) in Finland in 2009 to that in 2011?
Make the answer very short. 0.95. What is the ratio of the Value added (constant 2005 US$) of Gabon in 2009 to that in 2011?
Offer a terse response. 1.03. What is the ratio of the Value added (constant 2005 US$) in Mauritius in 2009 to that in 2011?
Give a very brief answer. 0.97. What is the ratio of the Value added (constant 2005 US$) in Portugal in 2009 to that in 2011?
Offer a very short reply. 0.99. What is the ratio of the Value added (constant 2005 US$) of Finland in 2010 to that in 2011?
Keep it short and to the point. 0.96. What is the ratio of the Value added (constant 2005 US$) of Gabon in 2010 to that in 2011?
Offer a very short reply. 0.98. What is the ratio of the Value added (constant 2005 US$) of Mauritius in 2010 to that in 2011?
Ensure brevity in your answer.  0.96. What is the difference between the highest and the second highest Value added (constant 2005 US$) in Finland?
Your response must be concise. 2.36e+08. What is the difference between the highest and the second highest Value added (constant 2005 US$) in Gabon?
Your answer should be very brief. 2.83e+07. What is the difference between the highest and the second highest Value added (constant 2005 US$) in Mauritius?
Offer a very short reply. 1.16e+07. What is the difference between the highest and the second highest Value added (constant 2005 US$) of Portugal?
Your answer should be very brief. 3.93e+07. What is the difference between the highest and the lowest Value added (constant 2005 US$) in Finland?
Provide a succinct answer. 8.74e+08. What is the difference between the highest and the lowest Value added (constant 2005 US$) in Gabon?
Make the answer very short. 9.51e+07. What is the difference between the highest and the lowest Value added (constant 2005 US$) of Mauritius?
Give a very brief answer. 5.09e+07. What is the difference between the highest and the lowest Value added (constant 2005 US$) of Portugal?
Offer a terse response. 1.98e+08. 